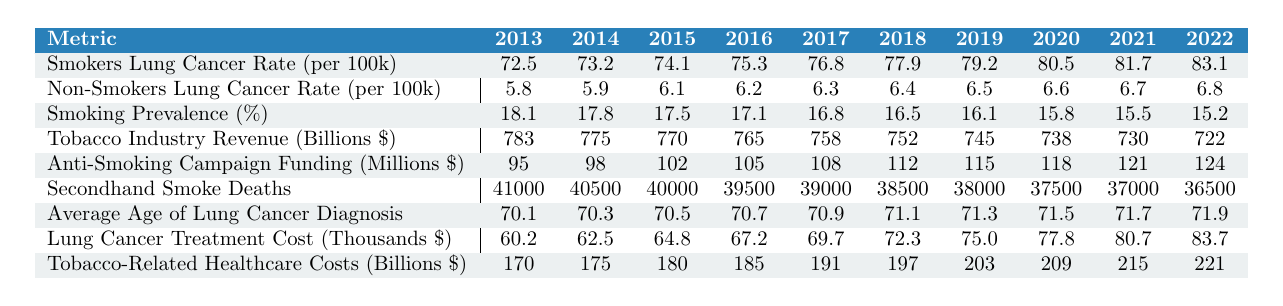What was the lung cancer rate per 100,000 for smokers in 2022? In 2022, the "Smokers Lung Cancer Rate per 100k" value listed in the table is 83.1.
Answer: 83.1 What was the lung cancer rate per 100,000 for non-smokers in 2013? In 2013, the "Non-Smokers Lung Cancer Rate per 100k" value from the table is 5.8.
Answer: 5.8 What is the difference in lung cancer rates per 100,000 between smokers and non-smokers in 2020? For 2020, the smoker's lung cancer rate is 80.5 and the non-smoker's rate is 6.6. The difference is 80.5 - 6.6 = 73.9.
Answer: 73.9 What was the average lung cancer rate per 100,000 for non-smokers over the past decade? To find the average, sum up the non-smoker rates for all years (5.8 + 5.9 + 6.1 + 6.2 + 6.3 + 6.4 + 6.5 + 6.6 + 6.7 + 6.8 = 63.3) and divide by 10, yielding an average of 6.33 per 100,000.
Answer: 6.33 Did the smoking prevalence percentage decrease from 2013 to 2022? The smoking prevalence percentages are 18.1 in 2013 and 15.2 in 2022, showing a decrease over the years, indicating that the statement is true.
Answer: Yes How much did the lung cancer treatment costs increase from 2013 to 2022? The treatment cost in 2013 is 60.2 thousand and in 2022 is 83.7 thousand. The increment is 83.7 - 60.2 = 23.5 thousand.
Answer: 23.5 What was the trend in tobacco-related healthcare costs from 2013 to 2022? The healthcare costs increased from 170 billion in 2013 to 221 billion in 2022, indicating an upward trend over the decade.
Answer: Upward trend What was the ratio of smokers to non-smokers lung cancer rates in 2019? In 2019, the smoker's rate is 79.2 and the non-smoker's rate is 6.5. The ratio is 79.2/6.5, which simplifies to approximately 12.2.
Answer: 12.2 Were the secondhand smoke deaths higher in 2013 or 2022? The secondhand smoke deaths in 2013 were 41,000, while in 2022 it was 36,500. Since 41,000 > 36,500, the count was higher in 2013.
Answer: 2013 What is the percentage increase in anti-smoking campaign funding from 2013 to 2022? The funding in 2013 was 95 million, and in 2022, it was 124 million. The increase is 124 - 95 = 29 million, which is (29/95) * 100 = 30.53% increase.
Answer: 30.53% 